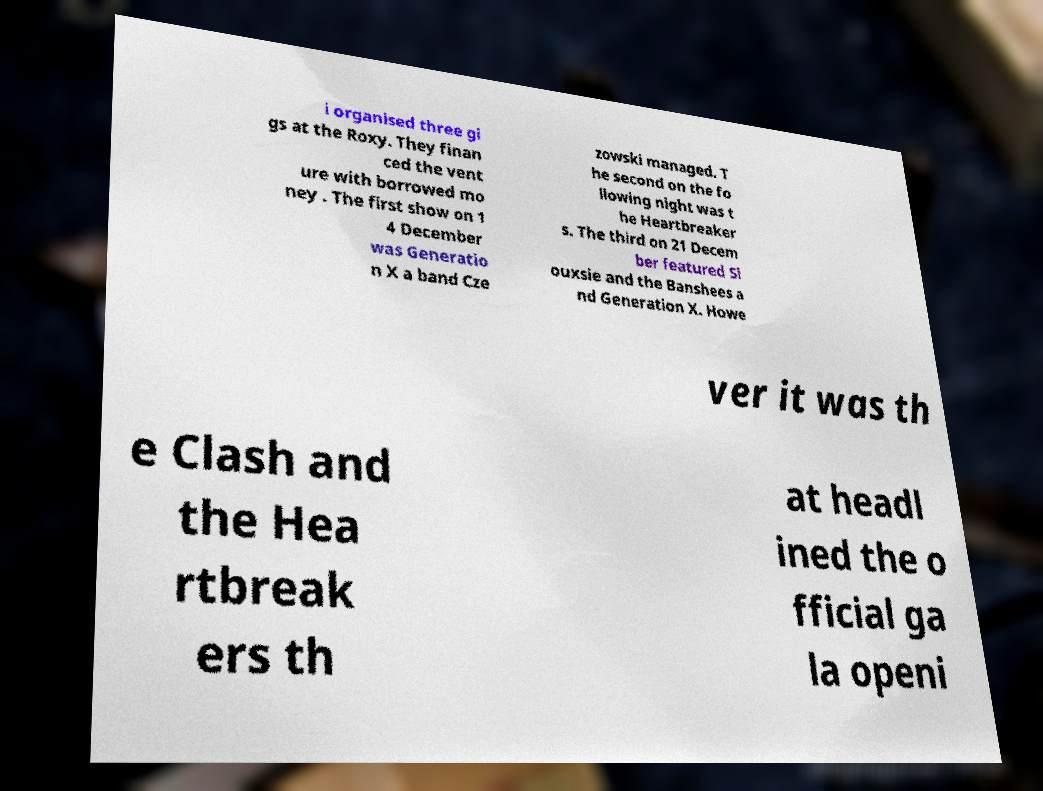Could you assist in decoding the text presented in this image and type it out clearly? i organised three gi gs at the Roxy. They finan ced the vent ure with borrowed mo ney . The first show on 1 4 December was Generatio n X a band Cze zowski managed. T he second on the fo llowing night was t he Heartbreaker s. The third on 21 Decem ber featured Si ouxsie and the Banshees a nd Generation X. Howe ver it was th e Clash and the Hea rtbreak ers th at headl ined the o fficial ga la openi 